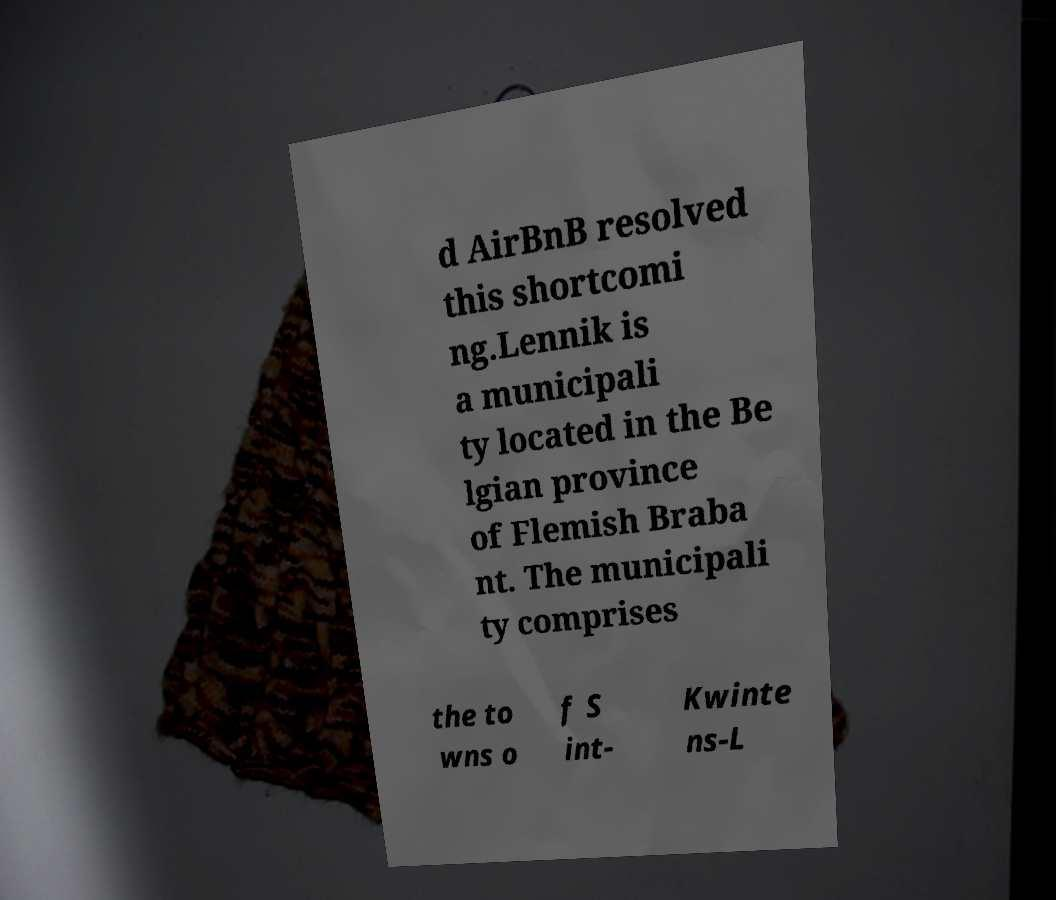Please identify and transcribe the text found in this image. d AirBnB resolved this shortcomi ng.Lennik is a municipali ty located in the Be lgian province of Flemish Braba nt. The municipali ty comprises the to wns o f S int- Kwinte ns-L 